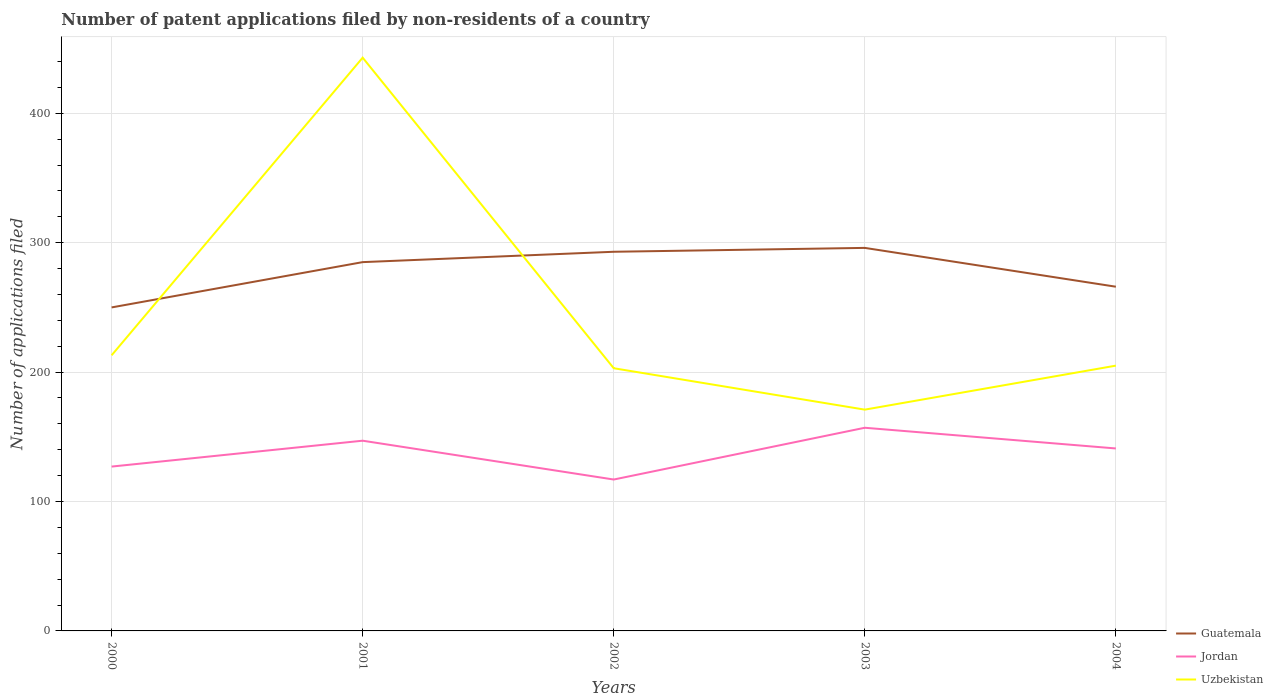How many different coloured lines are there?
Your answer should be very brief. 3. Is the number of lines equal to the number of legend labels?
Provide a succinct answer. Yes. Across all years, what is the maximum number of applications filed in Uzbekistan?
Your answer should be very brief. 171. What is the total number of applications filed in Guatemala in the graph?
Ensure brevity in your answer.  -46. What is the difference between the highest and the second highest number of applications filed in Uzbekistan?
Provide a short and direct response. 272. Is the number of applications filed in Uzbekistan strictly greater than the number of applications filed in Guatemala over the years?
Offer a very short reply. No. Does the graph contain grids?
Offer a terse response. Yes. How many legend labels are there?
Provide a short and direct response. 3. What is the title of the graph?
Provide a succinct answer. Number of patent applications filed by non-residents of a country. Does "Belgium" appear as one of the legend labels in the graph?
Your answer should be very brief. No. What is the label or title of the Y-axis?
Give a very brief answer. Number of applications filed. What is the Number of applications filed in Guatemala in 2000?
Your answer should be very brief. 250. What is the Number of applications filed in Jordan in 2000?
Offer a terse response. 127. What is the Number of applications filed of Uzbekistan in 2000?
Your answer should be very brief. 213. What is the Number of applications filed of Guatemala in 2001?
Keep it short and to the point. 285. What is the Number of applications filed of Jordan in 2001?
Keep it short and to the point. 147. What is the Number of applications filed in Uzbekistan in 2001?
Offer a terse response. 443. What is the Number of applications filed of Guatemala in 2002?
Keep it short and to the point. 293. What is the Number of applications filed of Jordan in 2002?
Ensure brevity in your answer.  117. What is the Number of applications filed of Uzbekistan in 2002?
Offer a very short reply. 203. What is the Number of applications filed of Guatemala in 2003?
Offer a terse response. 296. What is the Number of applications filed in Jordan in 2003?
Offer a very short reply. 157. What is the Number of applications filed in Uzbekistan in 2003?
Provide a short and direct response. 171. What is the Number of applications filed of Guatemala in 2004?
Your answer should be very brief. 266. What is the Number of applications filed of Jordan in 2004?
Provide a succinct answer. 141. What is the Number of applications filed of Uzbekistan in 2004?
Keep it short and to the point. 205. Across all years, what is the maximum Number of applications filed of Guatemala?
Make the answer very short. 296. Across all years, what is the maximum Number of applications filed of Jordan?
Offer a terse response. 157. Across all years, what is the maximum Number of applications filed of Uzbekistan?
Offer a terse response. 443. Across all years, what is the minimum Number of applications filed in Guatemala?
Your response must be concise. 250. Across all years, what is the minimum Number of applications filed of Jordan?
Provide a succinct answer. 117. Across all years, what is the minimum Number of applications filed of Uzbekistan?
Keep it short and to the point. 171. What is the total Number of applications filed in Guatemala in the graph?
Ensure brevity in your answer.  1390. What is the total Number of applications filed in Jordan in the graph?
Your answer should be compact. 689. What is the total Number of applications filed in Uzbekistan in the graph?
Offer a very short reply. 1235. What is the difference between the Number of applications filed of Guatemala in 2000 and that in 2001?
Your answer should be compact. -35. What is the difference between the Number of applications filed in Uzbekistan in 2000 and that in 2001?
Keep it short and to the point. -230. What is the difference between the Number of applications filed of Guatemala in 2000 and that in 2002?
Provide a short and direct response. -43. What is the difference between the Number of applications filed of Uzbekistan in 2000 and that in 2002?
Your response must be concise. 10. What is the difference between the Number of applications filed in Guatemala in 2000 and that in 2003?
Offer a very short reply. -46. What is the difference between the Number of applications filed in Jordan in 2000 and that in 2003?
Make the answer very short. -30. What is the difference between the Number of applications filed in Uzbekistan in 2000 and that in 2003?
Your answer should be compact. 42. What is the difference between the Number of applications filed in Guatemala in 2000 and that in 2004?
Make the answer very short. -16. What is the difference between the Number of applications filed in Jordan in 2000 and that in 2004?
Keep it short and to the point. -14. What is the difference between the Number of applications filed of Guatemala in 2001 and that in 2002?
Your answer should be very brief. -8. What is the difference between the Number of applications filed of Jordan in 2001 and that in 2002?
Your answer should be very brief. 30. What is the difference between the Number of applications filed of Uzbekistan in 2001 and that in 2002?
Ensure brevity in your answer.  240. What is the difference between the Number of applications filed of Guatemala in 2001 and that in 2003?
Offer a very short reply. -11. What is the difference between the Number of applications filed of Uzbekistan in 2001 and that in 2003?
Ensure brevity in your answer.  272. What is the difference between the Number of applications filed of Guatemala in 2001 and that in 2004?
Your answer should be compact. 19. What is the difference between the Number of applications filed of Jordan in 2001 and that in 2004?
Ensure brevity in your answer.  6. What is the difference between the Number of applications filed of Uzbekistan in 2001 and that in 2004?
Make the answer very short. 238. What is the difference between the Number of applications filed of Uzbekistan in 2002 and that in 2003?
Give a very brief answer. 32. What is the difference between the Number of applications filed of Jordan in 2002 and that in 2004?
Your answer should be compact. -24. What is the difference between the Number of applications filed of Jordan in 2003 and that in 2004?
Your answer should be very brief. 16. What is the difference between the Number of applications filed of Uzbekistan in 2003 and that in 2004?
Ensure brevity in your answer.  -34. What is the difference between the Number of applications filed in Guatemala in 2000 and the Number of applications filed in Jordan in 2001?
Ensure brevity in your answer.  103. What is the difference between the Number of applications filed in Guatemala in 2000 and the Number of applications filed in Uzbekistan in 2001?
Provide a short and direct response. -193. What is the difference between the Number of applications filed of Jordan in 2000 and the Number of applications filed of Uzbekistan in 2001?
Provide a succinct answer. -316. What is the difference between the Number of applications filed in Guatemala in 2000 and the Number of applications filed in Jordan in 2002?
Make the answer very short. 133. What is the difference between the Number of applications filed of Guatemala in 2000 and the Number of applications filed of Uzbekistan in 2002?
Your answer should be very brief. 47. What is the difference between the Number of applications filed of Jordan in 2000 and the Number of applications filed of Uzbekistan in 2002?
Your answer should be compact. -76. What is the difference between the Number of applications filed of Guatemala in 2000 and the Number of applications filed of Jordan in 2003?
Your response must be concise. 93. What is the difference between the Number of applications filed of Guatemala in 2000 and the Number of applications filed of Uzbekistan in 2003?
Make the answer very short. 79. What is the difference between the Number of applications filed of Jordan in 2000 and the Number of applications filed of Uzbekistan in 2003?
Offer a terse response. -44. What is the difference between the Number of applications filed of Guatemala in 2000 and the Number of applications filed of Jordan in 2004?
Offer a very short reply. 109. What is the difference between the Number of applications filed of Jordan in 2000 and the Number of applications filed of Uzbekistan in 2004?
Your response must be concise. -78. What is the difference between the Number of applications filed of Guatemala in 2001 and the Number of applications filed of Jordan in 2002?
Offer a terse response. 168. What is the difference between the Number of applications filed in Guatemala in 2001 and the Number of applications filed in Uzbekistan in 2002?
Your answer should be compact. 82. What is the difference between the Number of applications filed in Jordan in 2001 and the Number of applications filed in Uzbekistan in 2002?
Ensure brevity in your answer.  -56. What is the difference between the Number of applications filed in Guatemala in 2001 and the Number of applications filed in Jordan in 2003?
Offer a terse response. 128. What is the difference between the Number of applications filed in Guatemala in 2001 and the Number of applications filed in Uzbekistan in 2003?
Make the answer very short. 114. What is the difference between the Number of applications filed of Jordan in 2001 and the Number of applications filed of Uzbekistan in 2003?
Your response must be concise. -24. What is the difference between the Number of applications filed in Guatemala in 2001 and the Number of applications filed in Jordan in 2004?
Ensure brevity in your answer.  144. What is the difference between the Number of applications filed of Guatemala in 2001 and the Number of applications filed of Uzbekistan in 2004?
Offer a very short reply. 80. What is the difference between the Number of applications filed of Jordan in 2001 and the Number of applications filed of Uzbekistan in 2004?
Your answer should be very brief. -58. What is the difference between the Number of applications filed of Guatemala in 2002 and the Number of applications filed of Jordan in 2003?
Your answer should be very brief. 136. What is the difference between the Number of applications filed in Guatemala in 2002 and the Number of applications filed in Uzbekistan in 2003?
Your response must be concise. 122. What is the difference between the Number of applications filed of Jordan in 2002 and the Number of applications filed of Uzbekistan in 2003?
Make the answer very short. -54. What is the difference between the Number of applications filed in Guatemala in 2002 and the Number of applications filed in Jordan in 2004?
Make the answer very short. 152. What is the difference between the Number of applications filed in Jordan in 2002 and the Number of applications filed in Uzbekistan in 2004?
Provide a succinct answer. -88. What is the difference between the Number of applications filed of Guatemala in 2003 and the Number of applications filed of Jordan in 2004?
Your response must be concise. 155. What is the difference between the Number of applications filed of Guatemala in 2003 and the Number of applications filed of Uzbekistan in 2004?
Give a very brief answer. 91. What is the difference between the Number of applications filed of Jordan in 2003 and the Number of applications filed of Uzbekistan in 2004?
Offer a terse response. -48. What is the average Number of applications filed of Guatemala per year?
Keep it short and to the point. 278. What is the average Number of applications filed of Jordan per year?
Offer a terse response. 137.8. What is the average Number of applications filed of Uzbekistan per year?
Offer a very short reply. 247. In the year 2000, what is the difference between the Number of applications filed in Guatemala and Number of applications filed in Jordan?
Offer a terse response. 123. In the year 2000, what is the difference between the Number of applications filed in Guatemala and Number of applications filed in Uzbekistan?
Keep it short and to the point. 37. In the year 2000, what is the difference between the Number of applications filed of Jordan and Number of applications filed of Uzbekistan?
Your answer should be compact. -86. In the year 2001, what is the difference between the Number of applications filed of Guatemala and Number of applications filed of Jordan?
Make the answer very short. 138. In the year 2001, what is the difference between the Number of applications filed of Guatemala and Number of applications filed of Uzbekistan?
Your response must be concise. -158. In the year 2001, what is the difference between the Number of applications filed of Jordan and Number of applications filed of Uzbekistan?
Offer a very short reply. -296. In the year 2002, what is the difference between the Number of applications filed of Guatemala and Number of applications filed of Jordan?
Offer a very short reply. 176. In the year 2002, what is the difference between the Number of applications filed of Guatemala and Number of applications filed of Uzbekistan?
Your answer should be compact. 90. In the year 2002, what is the difference between the Number of applications filed in Jordan and Number of applications filed in Uzbekistan?
Your answer should be very brief. -86. In the year 2003, what is the difference between the Number of applications filed of Guatemala and Number of applications filed of Jordan?
Your response must be concise. 139. In the year 2003, what is the difference between the Number of applications filed in Guatemala and Number of applications filed in Uzbekistan?
Provide a succinct answer. 125. In the year 2004, what is the difference between the Number of applications filed in Guatemala and Number of applications filed in Jordan?
Provide a short and direct response. 125. In the year 2004, what is the difference between the Number of applications filed in Jordan and Number of applications filed in Uzbekistan?
Provide a succinct answer. -64. What is the ratio of the Number of applications filed of Guatemala in 2000 to that in 2001?
Your answer should be very brief. 0.88. What is the ratio of the Number of applications filed in Jordan in 2000 to that in 2001?
Offer a terse response. 0.86. What is the ratio of the Number of applications filed in Uzbekistan in 2000 to that in 2001?
Provide a succinct answer. 0.48. What is the ratio of the Number of applications filed of Guatemala in 2000 to that in 2002?
Offer a terse response. 0.85. What is the ratio of the Number of applications filed of Jordan in 2000 to that in 2002?
Ensure brevity in your answer.  1.09. What is the ratio of the Number of applications filed of Uzbekistan in 2000 to that in 2002?
Keep it short and to the point. 1.05. What is the ratio of the Number of applications filed in Guatemala in 2000 to that in 2003?
Provide a short and direct response. 0.84. What is the ratio of the Number of applications filed in Jordan in 2000 to that in 2003?
Your response must be concise. 0.81. What is the ratio of the Number of applications filed of Uzbekistan in 2000 to that in 2003?
Offer a terse response. 1.25. What is the ratio of the Number of applications filed of Guatemala in 2000 to that in 2004?
Your answer should be very brief. 0.94. What is the ratio of the Number of applications filed of Jordan in 2000 to that in 2004?
Offer a very short reply. 0.9. What is the ratio of the Number of applications filed in Uzbekistan in 2000 to that in 2004?
Your response must be concise. 1.04. What is the ratio of the Number of applications filed of Guatemala in 2001 to that in 2002?
Keep it short and to the point. 0.97. What is the ratio of the Number of applications filed in Jordan in 2001 to that in 2002?
Keep it short and to the point. 1.26. What is the ratio of the Number of applications filed of Uzbekistan in 2001 to that in 2002?
Make the answer very short. 2.18. What is the ratio of the Number of applications filed in Guatemala in 2001 to that in 2003?
Provide a succinct answer. 0.96. What is the ratio of the Number of applications filed in Jordan in 2001 to that in 2003?
Keep it short and to the point. 0.94. What is the ratio of the Number of applications filed in Uzbekistan in 2001 to that in 2003?
Ensure brevity in your answer.  2.59. What is the ratio of the Number of applications filed in Guatemala in 2001 to that in 2004?
Your answer should be very brief. 1.07. What is the ratio of the Number of applications filed in Jordan in 2001 to that in 2004?
Your answer should be compact. 1.04. What is the ratio of the Number of applications filed in Uzbekistan in 2001 to that in 2004?
Your answer should be compact. 2.16. What is the ratio of the Number of applications filed in Jordan in 2002 to that in 2003?
Provide a short and direct response. 0.75. What is the ratio of the Number of applications filed of Uzbekistan in 2002 to that in 2003?
Ensure brevity in your answer.  1.19. What is the ratio of the Number of applications filed in Guatemala in 2002 to that in 2004?
Provide a short and direct response. 1.1. What is the ratio of the Number of applications filed in Jordan in 2002 to that in 2004?
Make the answer very short. 0.83. What is the ratio of the Number of applications filed in Uzbekistan in 2002 to that in 2004?
Offer a terse response. 0.99. What is the ratio of the Number of applications filed of Guatemala in 2003 to that in 2004?
Offer a terse response. 1.11. What is the ratio of the Number of applications filed of Jordan in 2003 to that in 2004?
Give a very brief answer. 1.11. What is the ratio of the Number of applications filed in Uzbekistan in 2003 to that in 2004?
Your response must be concise. 0.83. What is the difference between the highest and the second highest Number of applications filed in Guatemala?
Your response must be concise. 3. What is the difference between the highest and the second highest Number of applications filed of Jordan?
Offer a very short reply. 10. What is the difference between the highest and the second highest Number of applications filed of Uzbekistan?
Your answer should be very brief. 230. What is the difference between the highest and the lowest Number of applications filed in Guatemala?
Make the answer very short. 46. What is the difference between the highest and the lowest Number of applications filed in Jordan?
Provide a succinct answer. 40. What is the difference between the highest and the lowest Number of applications filed in Uzbekistan?
Offer a terse response. 272. 